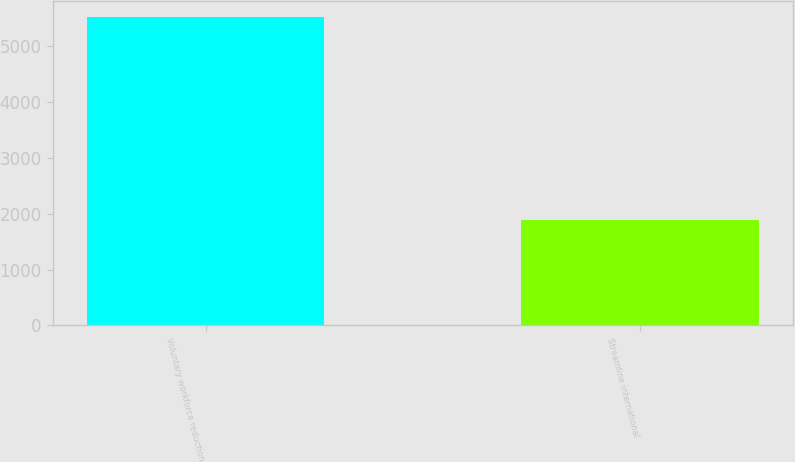Convert chart to OTSL. <chart><loc_0><loc_0><loc_500><loc_500><bar_chart><fcel>Voluntary workforce reduction<fcel>Streamline international<nl><fcel>5531<fcel>1896<nl></chart> 